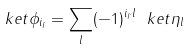Convert formula to latex. <formula><loc_0><loc_0><loc_500><loc_500>\ k e t { \phi _ { i _ { I } } } = \sum _ { l } ( - 1 ) ^ { i _ { I } \cdot l } \ k e t { \eta _ { l } }</formula> 